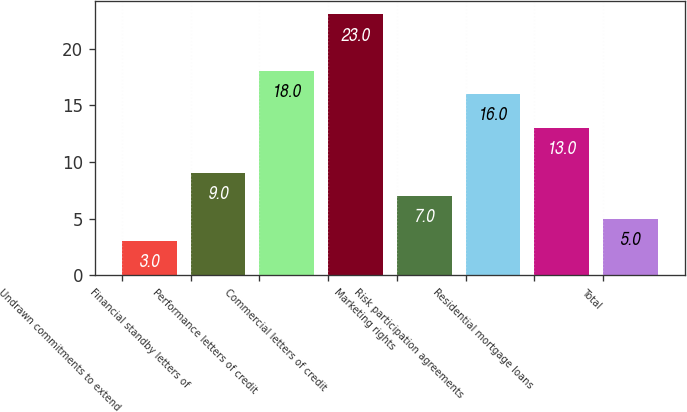<chart> <loc_0><loc_0><loc_500><loc_500><bar_chart><fcel>Undrawn commitments to extend<fcel>Financial standby letters of<fcel>Performance letters of credit<fcel>Commercial letters of credit<fcel>Marketing rights<fcel>Risk participation agreements<fcel>Residential mortgage loans<fcel>Total<nl><fcel>3<fcel>9<fcel>18<fcel>23<fcel>7<fcel>16<fcel>13<fcel>5<nl></chart> 